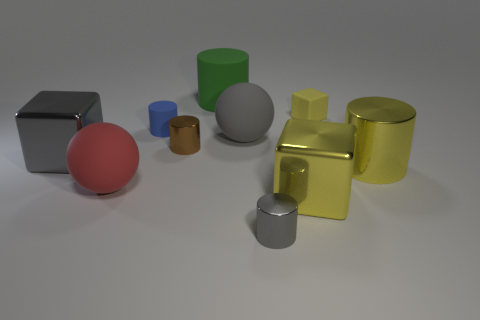Subtract all green cylinders. How many cylinders are left? 4 Subtract all yellow cylinders. How many cylinders are left? 4 Subtract all gray cylinders. Subtract all blue blocks. How many cylinders are left? 4 Subtract all blocks. How many objects are left? 7 Add 1 large yellow metal things. How many large yellow metal things exist? 3 Subtract 0 cyan blocks. How many objects are left? 10 Subtract all small yellow spheres. Subtract all large gray matte objects. How many objects are left? 9 Add 9 small blue rubber things. How many small blue rubber things are left? 10 